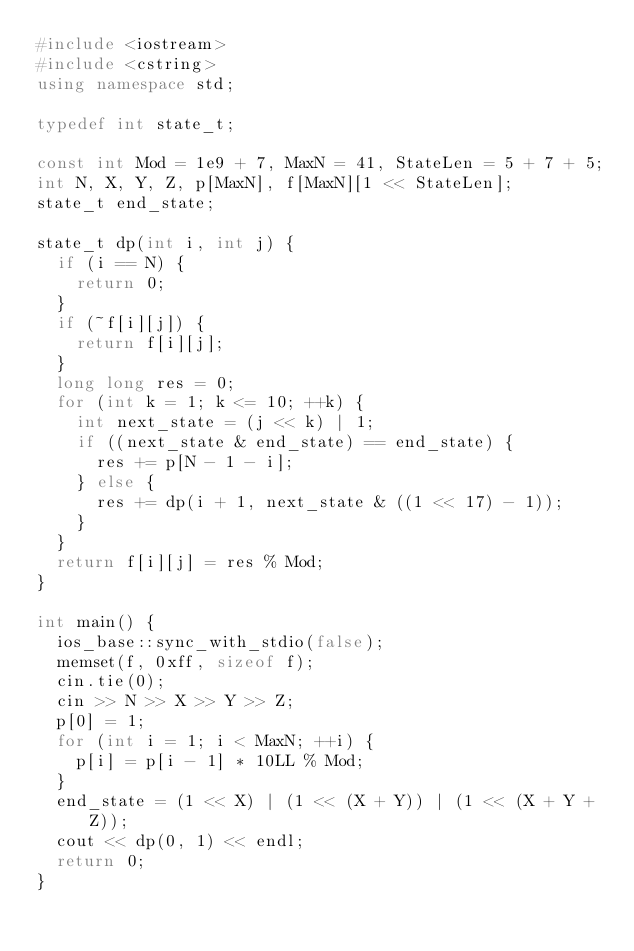Convert code to text. <code><loc_0><loc_0><loc_500><loc_500><_C++_>#include <iostream>
#include <cstring>
using namespace std;

typedef int state_t;

const int Mod = 1e9 + 7, MaxN = 41, StateLen = 5 + 7 + 5;
int N, X, Y, Z, p[MaxN], f[MaxN][1 << StateLen];
state_t end_state;

state_t dp(int i, int j) {
  if (i == N) {
    return 0;
  }
  if (~f[i][j]) {
    return f[i][j];
  }
  long long res = 0;
  for (int k = 1; k <= 10; ++k) {
    int next_state = (j << k) | 1;
    if ((next_state & end_state) == end_state) {
      res += p[N - 1 - i];
    } else {
      res += dp(i + 1, next_state & ((1 << 17) - 1));
    }
  }
  return f[i][j] = res % Mod;
}

int main() {
  ios_base::sync_with_stdio(false);
  memset(f, 0xff, sizeof f);
  cin.tie(0);
  cin >> N >> X >> Y >> Z;
  p[0] = 1;
  for (int i = 1; i < MaxN; ++i) {
    p[i] = p[i - 1] * 10LL % Mod;
  }
  end_state = (1 << X) | (1 << (X + Y)) | (1 << (X + Y + Z));
  cout << dp(0, 1) << endl;
  return 0;
}
</code> 